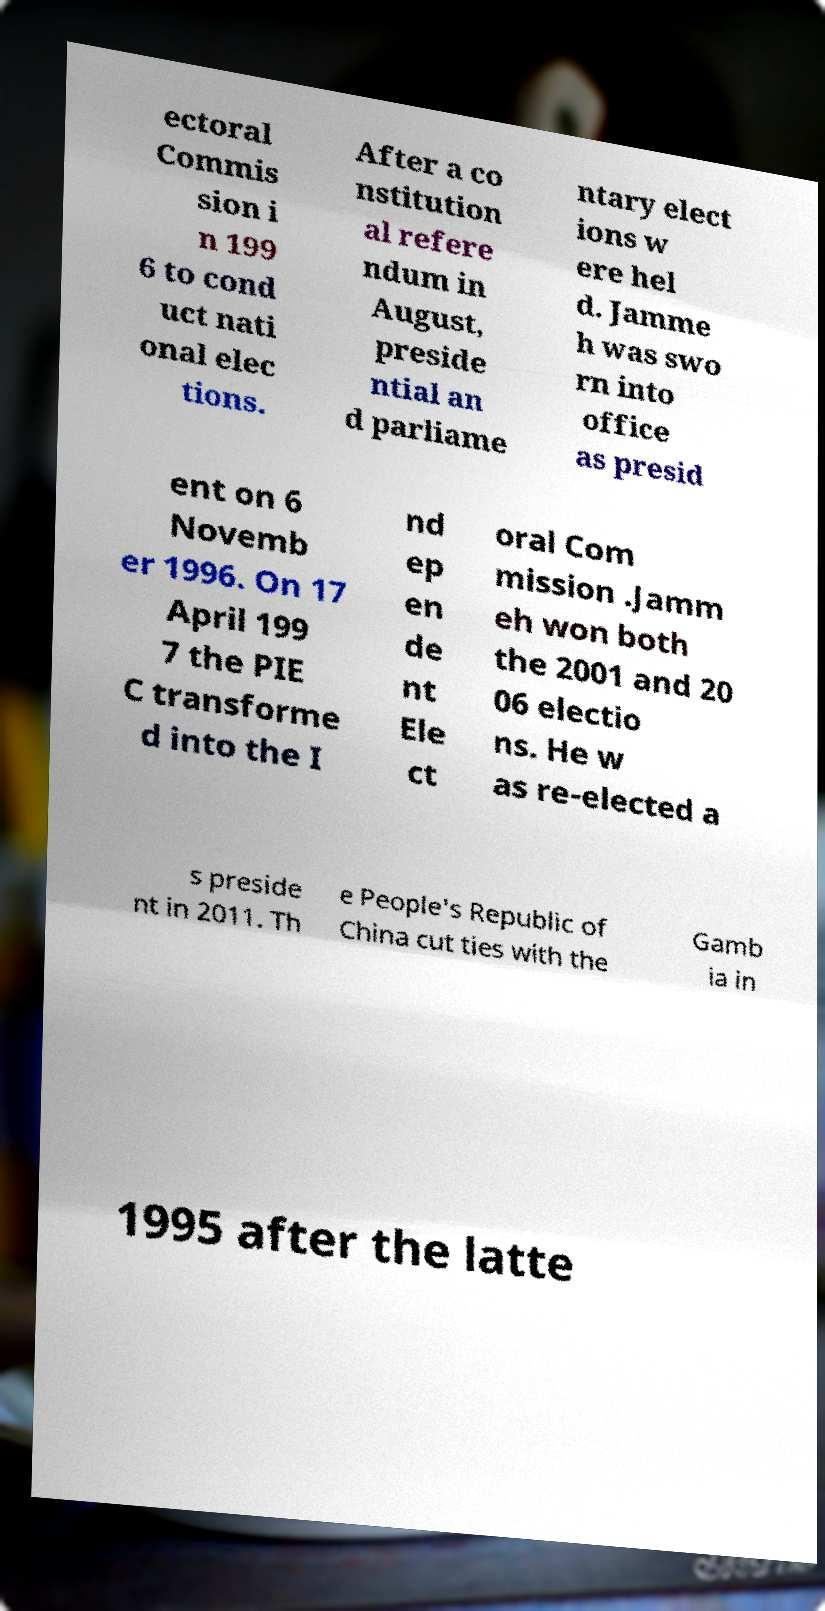Can you read and provide the text displayed in the image?This photo seems to have some interesting text. Can you extract and type it out for me? ectoral Commis sion i n 199 6 to cond uct nati onal elec tions. After a co nstitution al refere ndum in August, preside ntial an d parliame ntary elect ions w ere hel d. Jamme h was swo rn into office as presid ent on 6 Novemb er 1996. On 17 April 199 7 the PIE C transforme d into the I nd ep en de nt Ele ct oral Com mission .Jamm eh won both the 2001 and 20 06 electio ns. He w as re-elected a s preside nt in 2011. Th e People's Republic of China cut ties with the Gamb ia in 1995 after the latte 